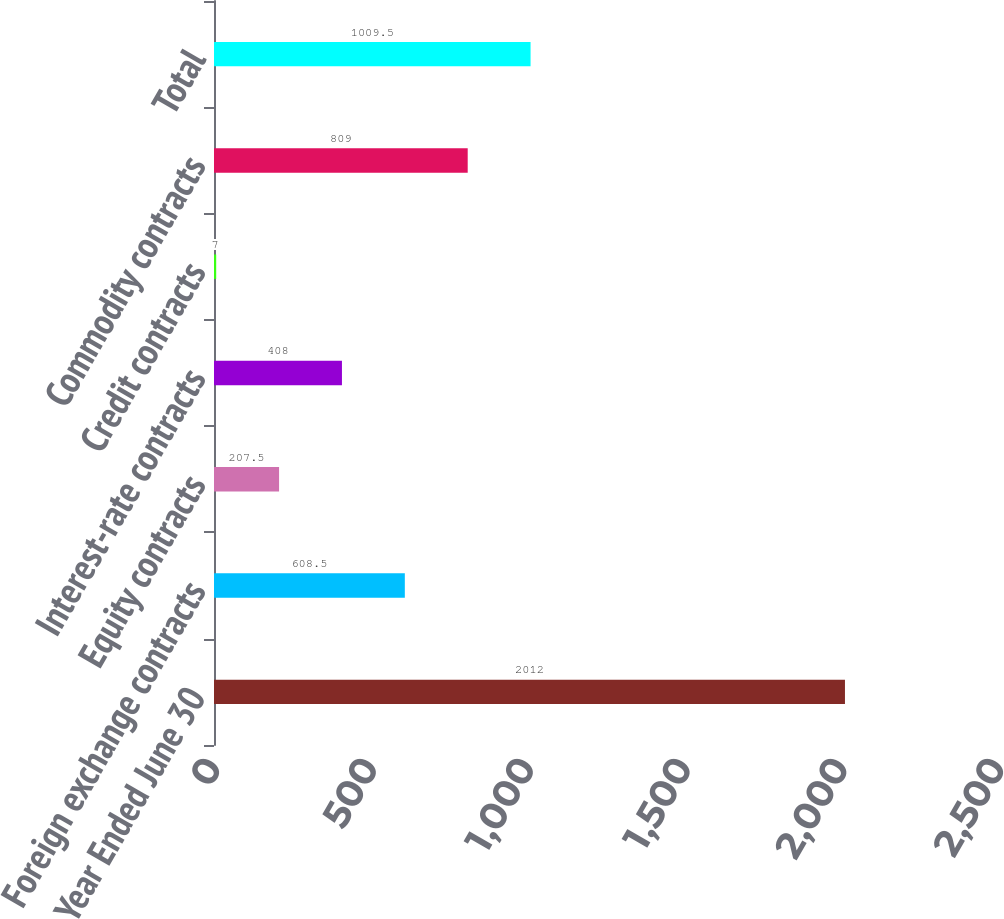Convert chart to OTSL. <chart><loc_0><loc_0><loc_500><loc_500><bar_chart><fcel>Year Ended June 30<fcel>Foreign exchange contracts<fcel>Equity contracts<fcel>Interest-rate contracts<fcel>Credit contracts<fcel>Commodity contracts<fcel>Total<nl><fcel>2012<fcel>608.5<fcel>207.5<fcel>408<fcel>7<fcel>809<fcel>1009.5<nl></chart> 